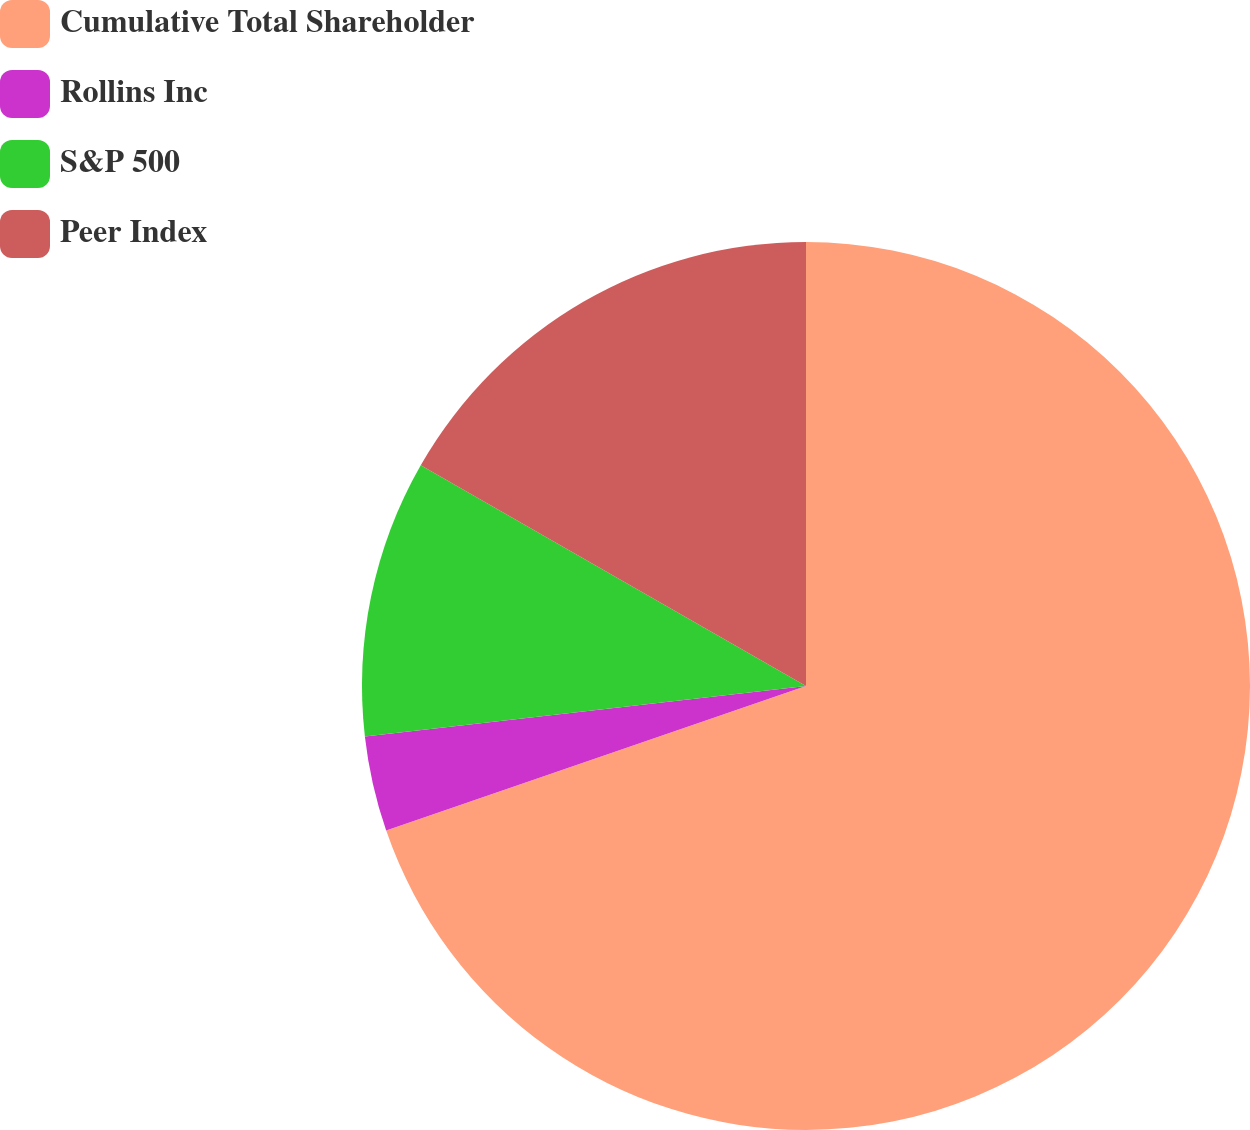<chart> <loc_0><loc_0><loc_500><loc_500><pie_chart><fcel>Cumulative Total Shareholder<fcel>Rollins Inc<fcel>S&P 500<fcel>Peer Index<nl><fcel>69.72%<fcel>3.47%<fcel>10.09%<fcel>16.72%<nl></chart> 